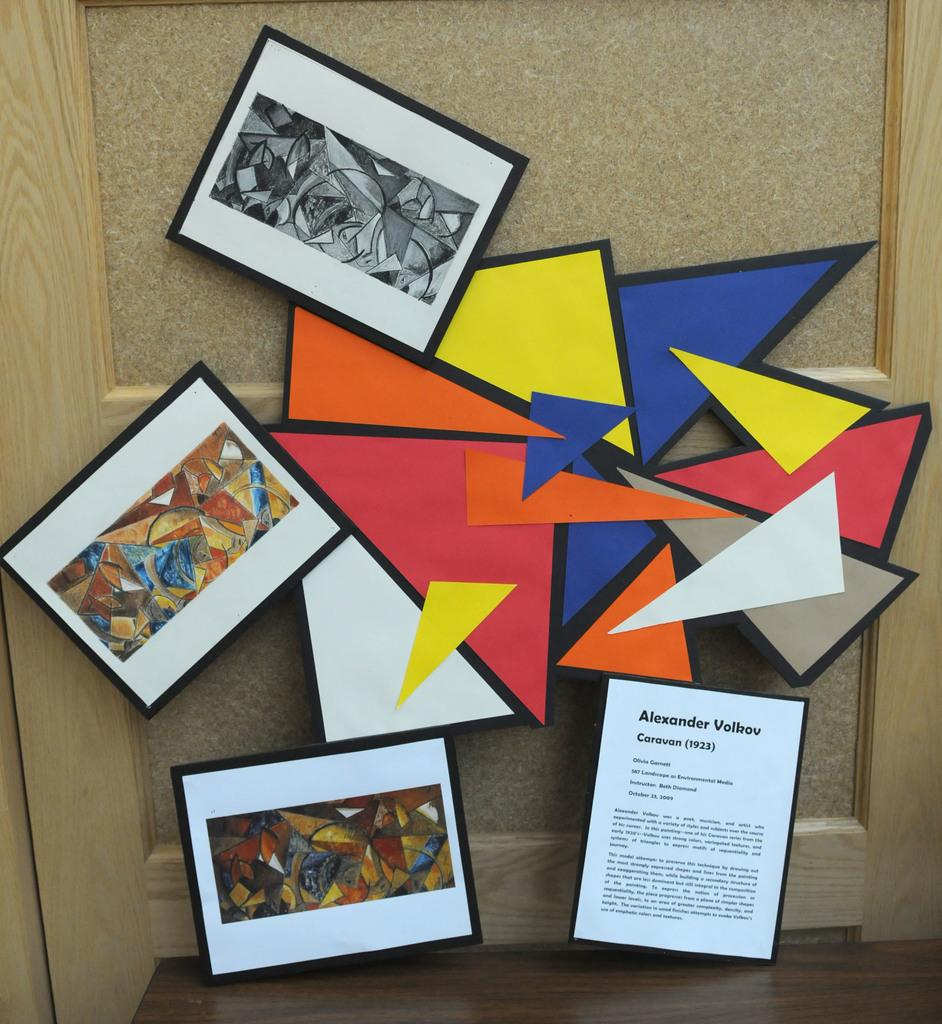<image>
Offer a succinct explanation of the picture presented. A display of framed art by Alexander Volkov. 